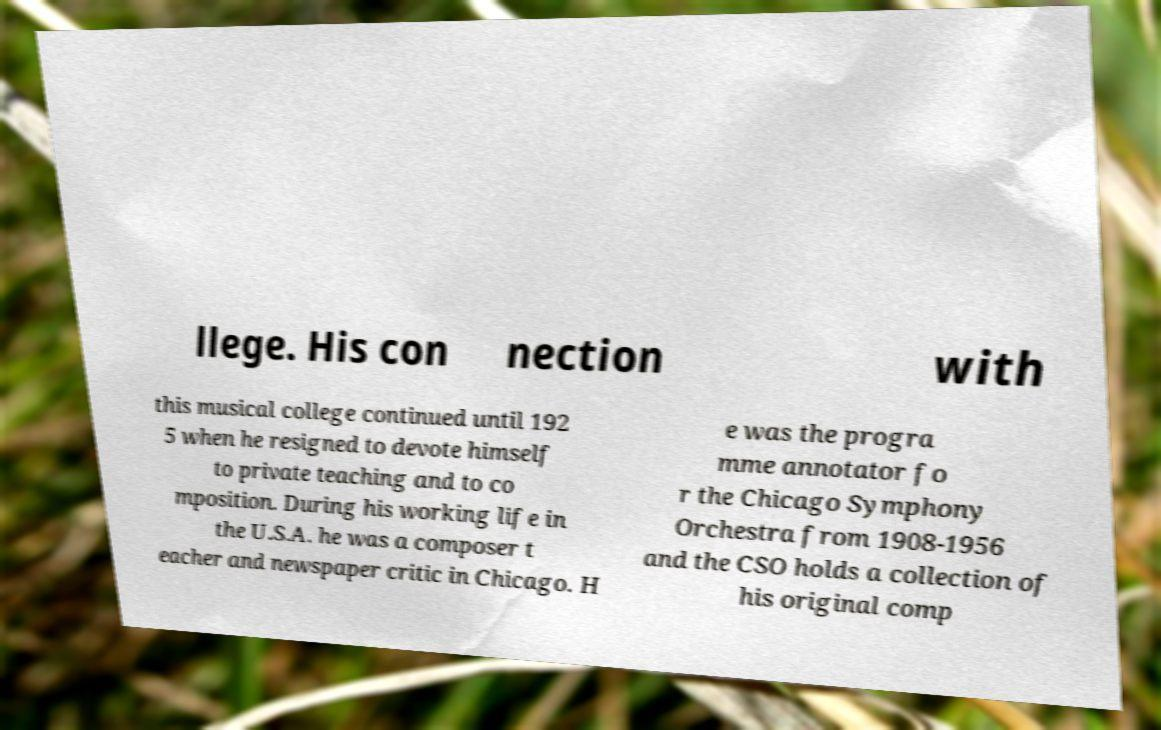I need the written content from this picture converted into text. Can you do that? llege. His con nection with this musical college continued until 192 5 when he resigned to devote himself to private teaching and to co mposition. During his working life in the U.S.A. he was a composer t eacher and newspaper critic in Chicago. H e was the progra mme annotator fo r the Chicago Symphony Orchestra from 1908-1956 and the CSO holds a collection of his original comp 